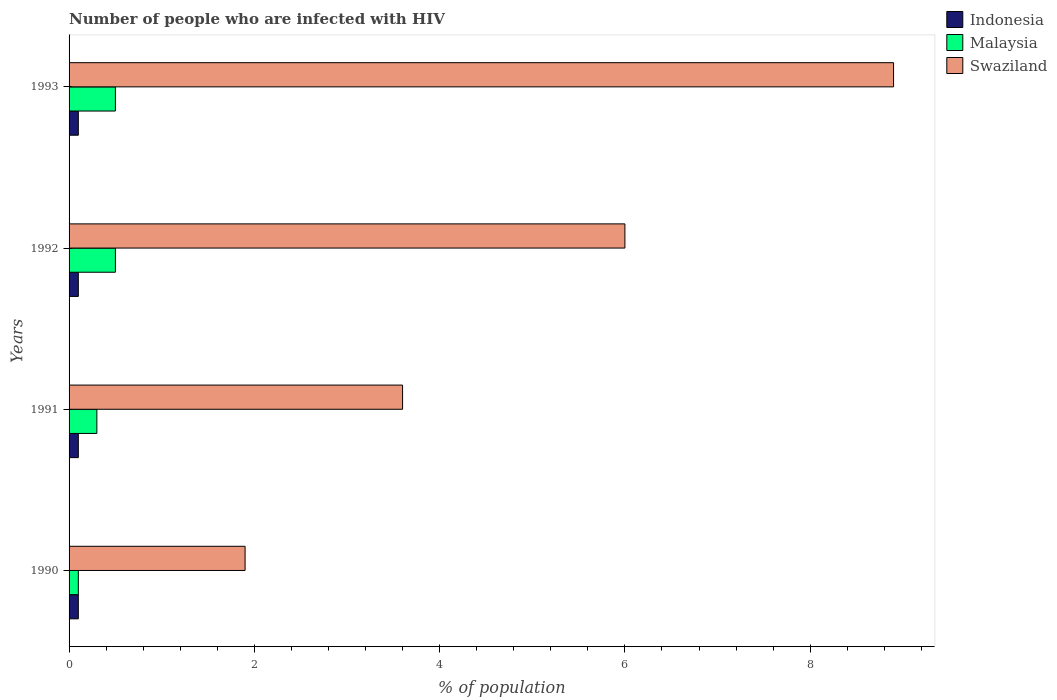How many groups of bars are there?
Provide a succinct answer. 4. Are the number of bars per tick equal to the number of legend labels?
Give a very brief answer. Yes. How many bars are there on the 4th tick from the top?
Keep it short and to the point. 3. How many bars are there on the 1st tick from the bottom?
Offer a very short reply. 3. What is the label of the 1st group of bars from the top?
Make the answer very short. 1993. In how many cases, is the number of bars for a given year not equal to the number of legend labels?
Provide a short and direct response. 0. What is the percentage of HIV infected population in in Swaziland in 1991?
Offer a terse response. 3.6. Across all years, what is the maximum percentage of HIV infected population in in Indonesia?
Offer a terse response. 0.1. In which year was the percentage of HIV infected population in in Indonesia maximum?
Your answer should be very brief. 1990. In which year was the percentage of HIV infected population in in Malaysia minimum?
Provide a short and direct response. 1990. What is the total percentage of HIV infected population in in Indonesia in the graph?
Provide a short and direct response. 0.4. What is the difference between the percentage of HIV infected population in in Swaziland in 1990 and that in 1991?
Give a very brief answer. -1.7. What is the average percentage of HIV infected population in in Swaziland per year?
Provide a succinct answer. 5.1. In the year 1991, what is the difference between the percentage of HIV infected population in in Malaysia and percentage of HIV infected population in in Indonesia?
Keep it short and to the point. 0.2. In how many years, is the percentage of HIV infected population in in Indonesia greater than 3.6 %?
Keep it short and to the point. 0. Is the difference between the percentage of HIV infected population in in Malaysia in 1990 and 1991 greater than the difference between the percentage of HIV infected population in in Indonesia in 1990 and 1991?
Offer a very short reply. No. What is the difference between the highest and the second highest percentage of HIV infected population in in Indonesia?
Make the answer very short. 0. What is the difference between the highest and the lowest percentage of HIV infected population in in Indonesia?
Ensure brevity in your answer.  0. What does the 2nd bar from the bottom in 1992 represents?
Provide a short and direct response. Malaysia. Is it the case that in every year, the sum of the percentage of HIV infected population in in Malaysia and percentage of HIV infected population in in Swaziland is greater than the percentage of HIV infected population in in Indonesia?
Offer a very short reply. Yes. How many bars are there?
Ensure brevity in your answer.  12. How many years are there in the graph?
Your answer should be compact. 4. What is the difference between two consecutive major ticks on the X-axis?
Provide a short and direct response. 2. Does the graph contain any zero values?
Offer a terse response. No. Where does the legend appear in the graph?
Your answer should be very brief. Top right. How many legend labels are there?
Offer a very short reply. 3. How are the legend labels stacked?
Make the answer very short. Vertical. What is the title of the graph?
Make the answer very short. Number of people who are infected with HIV. Does "Egypt, Arab Rep." appear as one of the legend labels in the graph?
Your response must be concise. No. What is the label or title of the X-axis?
Provide a short and direct response. % of population. What is the label or title of the Y-axis?
Offer a terse response. Years. What is the % of population in Malaysia in 1990?
Offer a very short reply. 0.1. What is the % of population in Swaziland in 1990?
Make the answer very short. 1.9. What is the % of population of Swaziland in 1992?
Your response must be concise. 6. What is the % of population of Malaysia in 1993?
Keep it short and to the point. 0.5. What is the % of population of Swaziland in 1993?
Make the answer very short. 8.9. Across all years, what is the maximum % of population of Swaziland?
Provide a succinct answer. 8.9. Across all years, what is the minimum % of population in Malaysia?
Offer a very short reply. 0.1. Across all years, what is the minimum % of population in Swaziland?
Your answer should be compact. 1.9. What is the total % of population of Swaziland in the graph?
Your answer should be very brief. 20.4. What is the difference between the % of population of Indonesia in 1990 and that in 1991?
Offer a terse response. 0. What is the difference between the % of population of Malaysia in 1990 and that in 1991?
Offer a very short reply. -0.2. What is the difference between the % of population in Swaziland in 1990 and that in 1991?
Provide a succinct answer. -1.7. What is the difference between the % of population of Indonesia in 1990 and that in 1992?
Provide a succinct answer. 0. What is the difference between the % of population in Malaysia in 1990 and that in 1992?
Provide a succinct answer. -0.4. What is the difference between the % of population of Indonesia in 1990 and that in 1993?
Provide a succinct answer. 0. What is the difference between the % of population of Swaziland in 1990 and that in 1993?
Keep it short and to the point. -7. What is the difference between the % of population in Malaysia in 1991 and that in 1992?
Ensure brevity in your answer.  -0.2. What is the difference between the % of population of Indonesia in 1991 and that in 1993?
Your answer should be compact. 0. What is the difference between the % of population in Malaysia in 1991 and that in 1993?
Ensure brevity in your answer.  -0.2. What is the difference between the % of population in Swaziland in 1991 and that in 1993?
Offer a very short reply. -5.3. What is the difference between the % of population in Indonesia in 1992 and that in 1993?
Your response must be concise. 0. What is the difference between the % of population in Malaysia in 1992 and that in 1993?
Offer a very short reply. 0. What is the difference between the % of population of Indonesia in 1990 and the % of population of Malaysia in 1991?
Give a very brief answer. -0.2. What is the difference between the % of population in Indonesia in 1990 and the % of population in Swaziland in 1991?
Provide a short and direct response. -3.5. What is the difference between the % of population of Indonesia in 1990 and the % of population of Swaziland in 1993?
Your response must be concise. -8.8. What is the difference between the % of population in Malaysia in 1990 and the % of population in Swaziland in 1993?
Your answer should be compact. -8.8. What is the difference between the % of population in Indonesia in 1991 and the % of population in Malaysia in 1992?
Your response must be concise. -0.4. What is the difference between the % of population in Indonesia in 1991 and the % of population in Swaziland in 1992?
Offer a terse response. -5.9. What is the difference between the % of population of Malaysia in 1991 and the % of population of Swaziland in 1992?
Your answer should be compact. -5.7. What is the difference between the % of population in Indonesia in 1991 and the % of population in Swaziland in 1993?
Your answer should be very brief. -8.8. What is the difference between the % of population in Indonesia in 1992 and the % of population in Malaysia in 1993?
Offer a very short reply. -0.4. What is the difference between the % of population of Indonesia in 1992 and the % of population of Swaziland in 1993?
Make the answer very short. -8.8. What is the average % of population in Indonesia per year?
Provide a succinct answer. 0.1. What is the average % of population of Malaysia per year?
Your answer should be very brief. 0.35. What is the average % of population in Swaziland per year?
Your answer should be compact. 5.1. In the year 1990, what is the difference between the % of population in Indonesia and % of population in Malaysia?
Offer a terse response. 0. In the year 1992, what is the difference between the % of population of Indonesia and % of population of Swaziland?
Your response must be concise. -5.9. In the year 1993, what is the difference between the % of population of Indonesia and % of population of Swaziland?
Make the answer very short. -8.8. What is the ratio of the % of population of Indonesia in 1990 to that in 1991?
Your answer should be very brief. 1. What is the ratio of the % of population of Swaziland in 1990 to that in 1991?
Your response must be concise. 0.53. What is the ratio of the % of population of Indonesia in 1990 to that in 1992?
Provide a short and direct response. 1. What is the ratio of the % of population in Swaziland in 1990 to that in 1992?
Give a very brief answer. 0.32. What is the ratio of the % of population of Indonesia in 1990 to that in 1993?
Offer a very short reply. 1. What is the ratio of the % of population of Malaysia in 1990 to that in 1993?
Ensure brevity in your answer.  0.2. What is the ratio of the % of population in Swaziland in 1990 to that in 1993?
Your answer should be compact. 0.21. What is the ratio of the % of population of Indonesia in 1991 to that in 1993?
Make the answer very short. 1. What is the ratio of the % of population in Swaziland in 1991 to that in 1993?
Ensure brevity in your answer.  0.4. What is the ratio of the % of population of Swaziland in 1992 to that in 1993?
Provide a succinct answer. 0.67. What is the difference between the highest and the lowest % of population of Indonesia?
Make the answer very short. 0. What is the difference between the highest and the lowest % of population in Swaziland?
Make the answer very short. 7. 